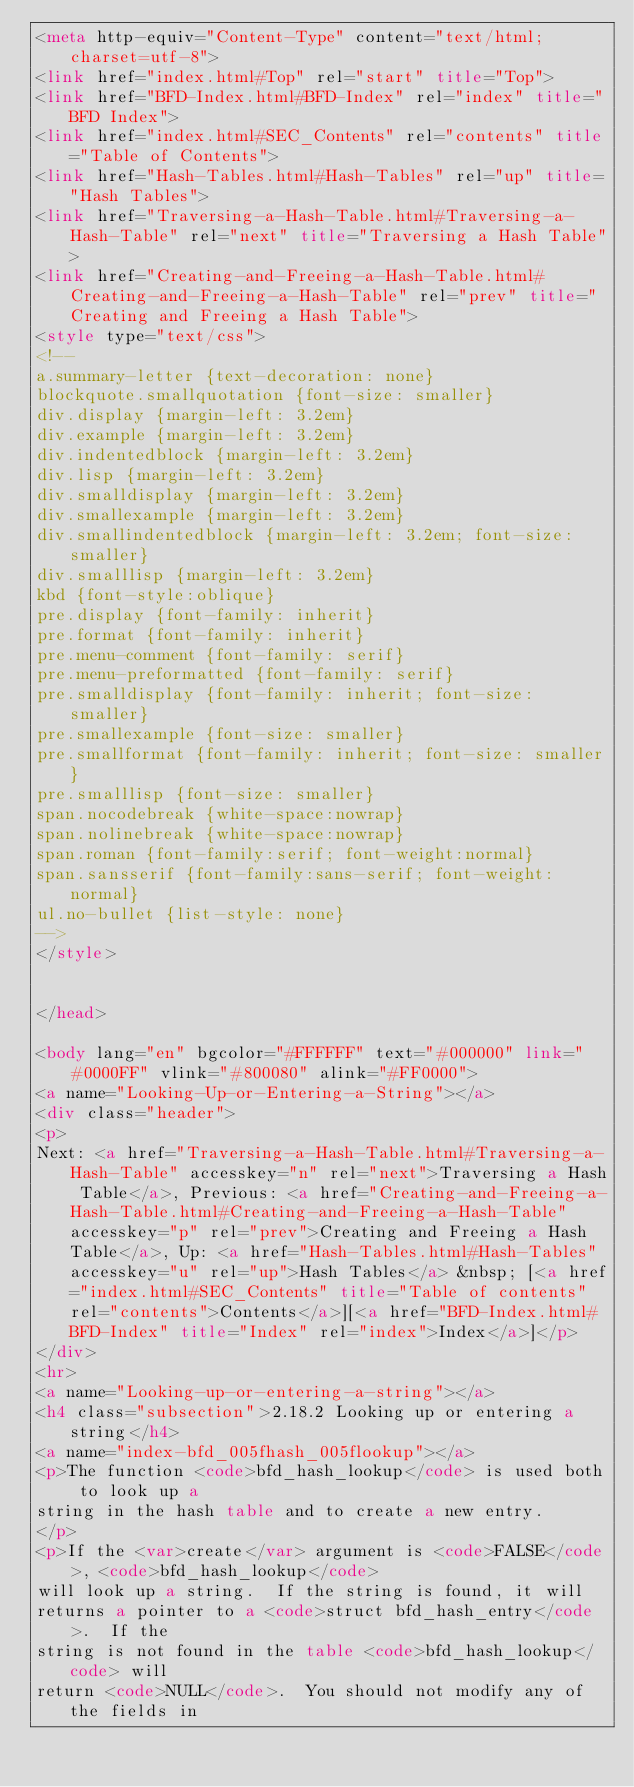<code> <loc_0><loc_0><loc_500><loc_500><_HTML_><meta http-equiv="Content-Type" content="text/html; charset=utf-8">
<link href="index.html#Top" rel="start" title="Top">
<link href="BFD-Index.html#BFD-Index" rel="index" title="BFD Index">
<link href="index.html#SEC_Contents" rel="contents" title="Table of Contents">
<link href="Hash-Tables.html#Hash-Tables" rel="up" title="Hash Tables">
<link href="Traversing-a-Hash-Table.html#Traversing-a-Hash-Table" rel="next" title="Traversing a Hash Table">
<link href="Creating-and-Freeing-a-Hash-Table.html#Creating-and-Freeing-a-Hash-Table" rel="prev" title="Creating and Freeing a Hash Table">
<style type="text/css">
<!--
a.summary-letter {text-decoration: none}
blockquote.smallquotation {font-size: smaller}
div.display {margin-left: 3.2em}
div.example {margin-left: 3.2em}
div.indentedblock {margin-left: 3.2em}
div.lisp {margin-left: 3.2em}
div.smalldisplay {margin-left: 3.2em}
div.smallexample {margin-left: 3.2em}
div.smallindentedblock {margin-left: 3.2em; font-size: smaller}
div.smalllisp {margin-left: 3.2em}
kbd {font-style:oblique}
pre.display {font-family: inherit}
pre.format {font-family: inherit}
pre.menu-comment {font-family: serif}
pre.menu-preformatted {font-family: serif}
pre.smalldisplay {font-family: inherit; font-size: smaller}
pre.smallexample {font-size: smaller}
pre.smallformat {font-family: inherit; font-size: smaller}
pre.smalllisp {font-size: smaller}
span.nocodebreak {white-space:nowrap}
span.nolinebreak {white-space:nowrap}
span.roman {font-family:serif; font-weight:normal}
span.sansserif {font-family:sans-serif; font-weight:normal}
ul.no-bullet {list-style: none}
-->
</style>


</head>

<body lang="en" bgcolor="#FFFFFF" text="#000000" link="#0000FF" vlink="#800080" alink="#FF0000">
<a name="Looking-Up-or-Entering-a-String"></a>
<div class="header">
<p>
Next: <a href="Traversing-a-Hash-Table.html#Traversing-a-Hash-Table" accesskey="n" rel="next">Traversing a Hash Table</a>, Previous: <a href="Creating-and-Freeing-a-Hash-Table.html#Creating-and-Freeing-a-Hash-Table" accesskey="p" rel="prev">Creating and Freeing a Hash Table</a>, Up: <a href="Hash-Tables.html#Hash-Tables" accesskey="u" rel="up">Hash Tables</a> &nbsp; [<a href="index.html#SEC_Contents" title="Table of contents" rel="contents">Contents</a>][<a href="BFD-Index.html#BFD-Index" title="Index" rel="index">Index</a>]</p>
</div>
<hr>
<a name="Looking-up-or-entering-a-string"></a>
<h4 class="subsection">2.18.2 Looking up or entering a string</h4>
<a name="index-bfd_005fhash_005flookup"></a>
<p>The function <code>bfd_hash_lookup</code> is used both to look up a
string in the hash table and to create a new entry.
</p>
<p>If the <var>create</var> argument is <code>FALSE</code>, <code>bfd_hash_lookup</code>
will look up a string.  If the string is found, it will
returns a pointer to a <code>struct bfd_hash_entry</code>.  If the
string is not found in the table <code>bfd_hash_lookup</code> will
return <code>NULL</code>.  You should not modify any of the fields in</code> 